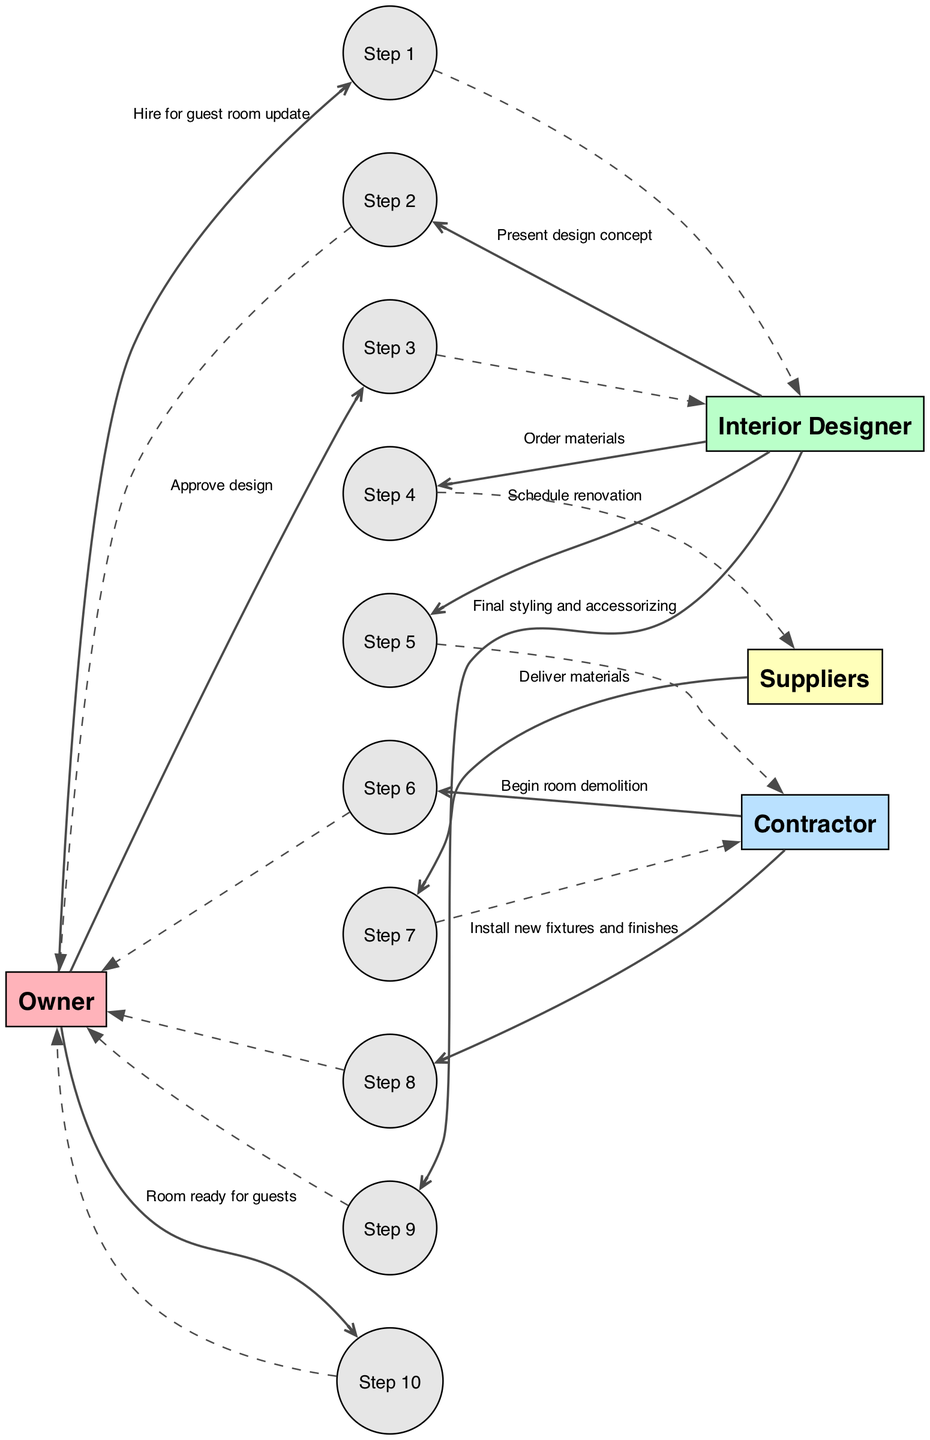What is the first action taken in the renovation timeline? The first action is "Hire for guest room update," which is initiated by the Owner to the Interior Designer.
Answer: Hire for guest room update Who presents the design concept to the Owner? The design concept is presented by the Interior Designer to the Owner, as indicated in the sequence diagram.
Answer: Interior Designer How many steps are included in the renovation timeline? There are a total of ten steps listed in the sequence of actions taken for the renovation project.
Answer: 10 What message does the Contractor send to the Owner after beginning the room demolition? After beginning the room demolition, the Contractor sends "Install new fixtures and finishes" to the Owner.
Answer: Install new fixtures and finishes Which actor is responsible for delivering materials to the Contractor? The Suppliers are responsible for delivering materials to the Contractor as shown in the sequence.
Answer: Suppliers What is the final action in the renovation project timeline? The final action is "Room ready for guests," which the Owner confirms after the renovation is complete.
Answer: Room ready for guests Which actor is involved in both ordering materials and final styling? The Interior Designer is involved in both ordering materials to the Suppliers and the final styling and accessorizing of the room.
Answer: Interior Designer What happens after the Owner approves the design? After the Owner approves the design, the Interior Designer proceeds to order materials and schedule renovation with the Contractor.
Answer: Order materials and schedule renovation How does the diagram display the flow of actions? The flow of actions is displayed in a left-to-right sequence where each step follows the previous one, clearly illustrating the progression of the renovation timeline.
Answer: Left-to-right sequence 